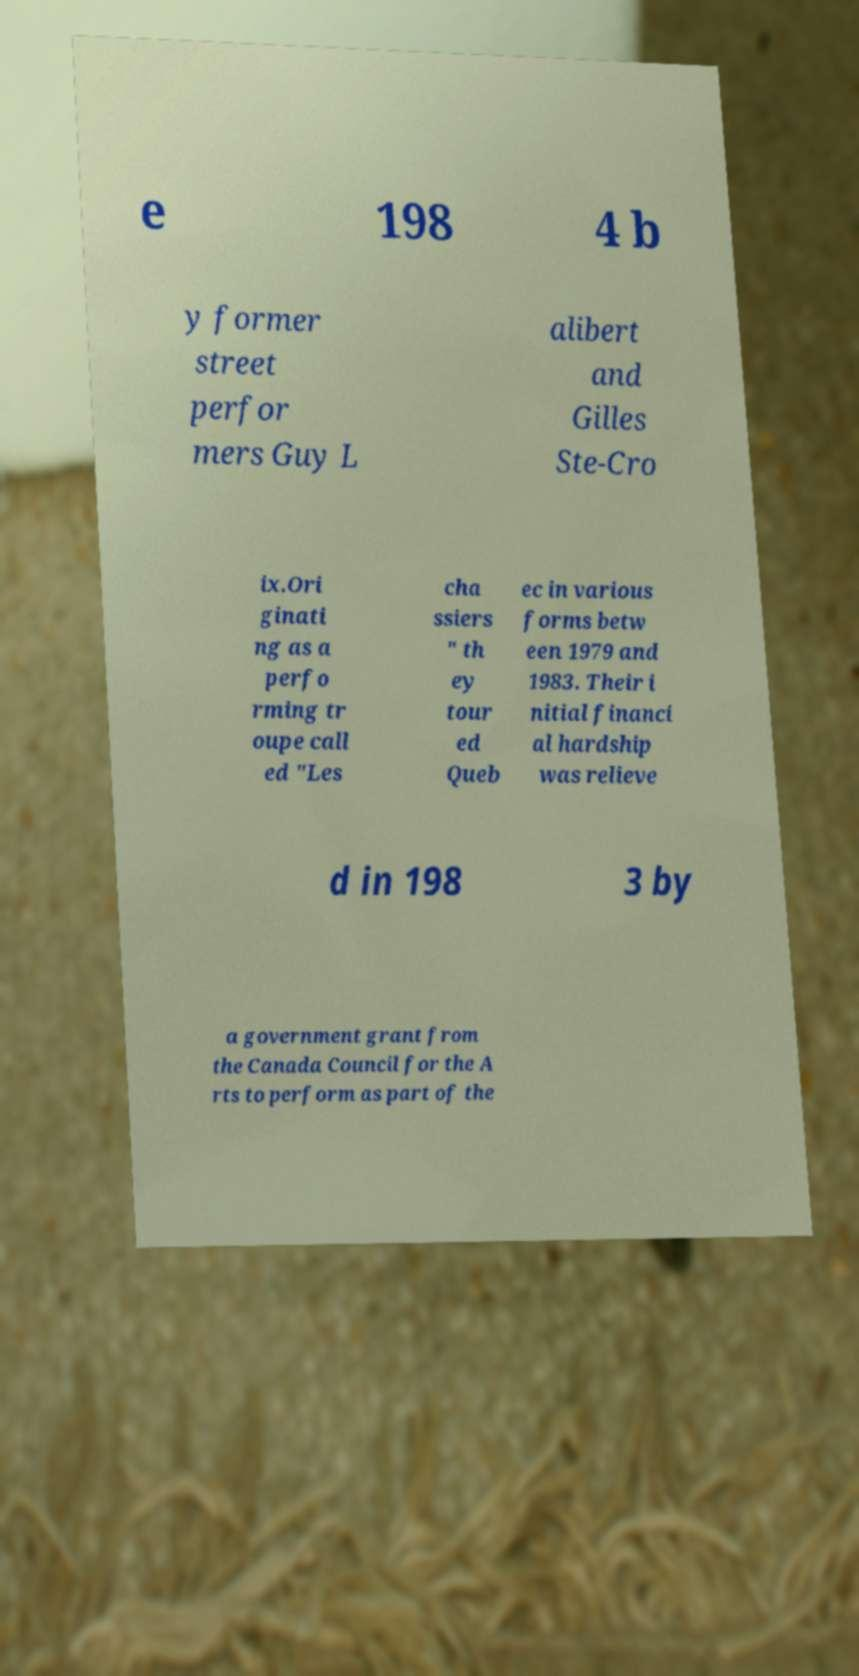For documentation purposes, I need the text within this image transcribed. Could you provide that? e 198 4 b y former street perfor mers Guy L alibert and Gilles Ste-Cro ix.Ori ginati ng as a perfo rming tr oupe call ed "Les cha ssiers " th ey tour ed Queb ec in various forms betw een 1979 and 1983. Their i nitial financi al hardship was relieve d in 198 3 by a government grant from the Canada Council for the A rts to perform as part of the 